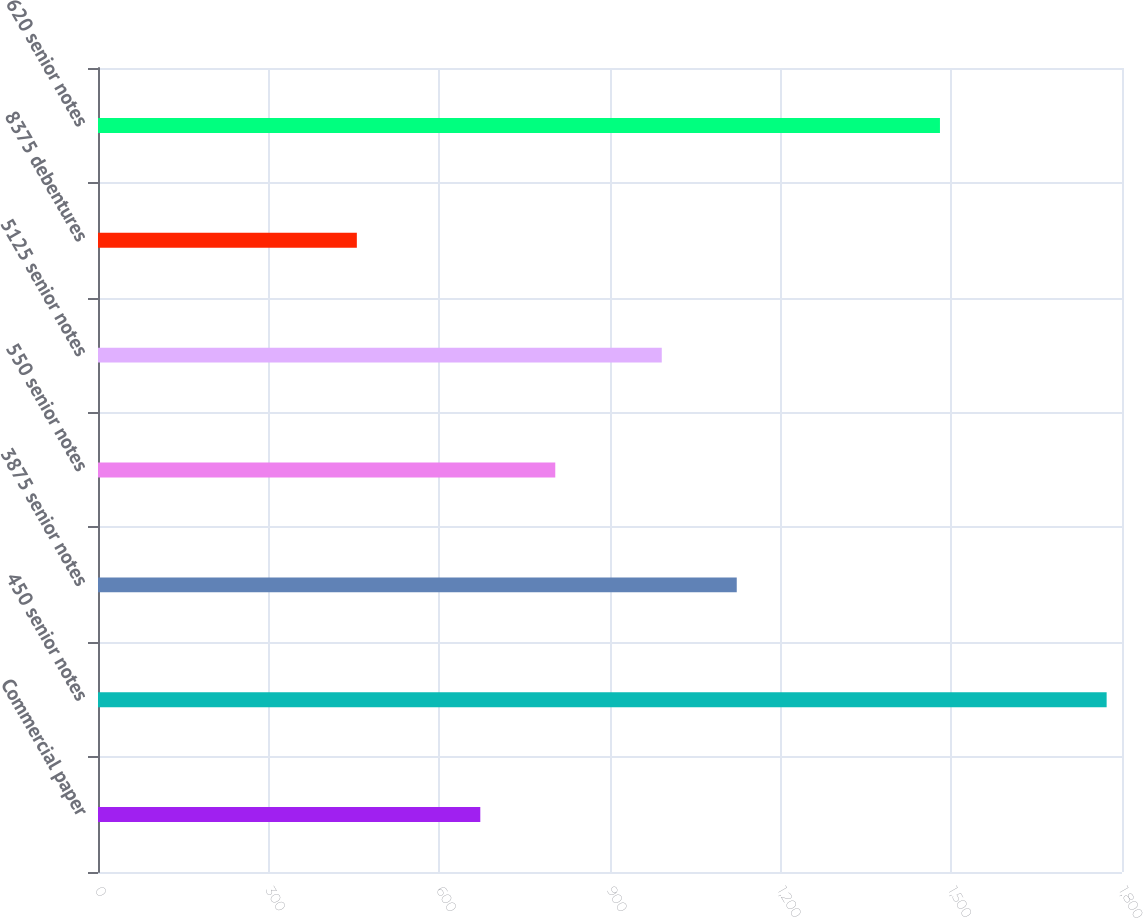Convert chart to OTSL. <chart><loc_0><loc_0><loc_500><loc_500><bar_chart><fcel>Commercial paper<fcel>450 senior notes<fcel>3875 senior notes<fcel>550 senior notes<fcel>5125 senior notes<fcel>8375 debentures<fcel>620 senior notes<nl><fcel>672<fcel>1773<fcel>1122.8<fcel>803.8<fcel>991<fcel>455<fcel>1480<nl></chart> 